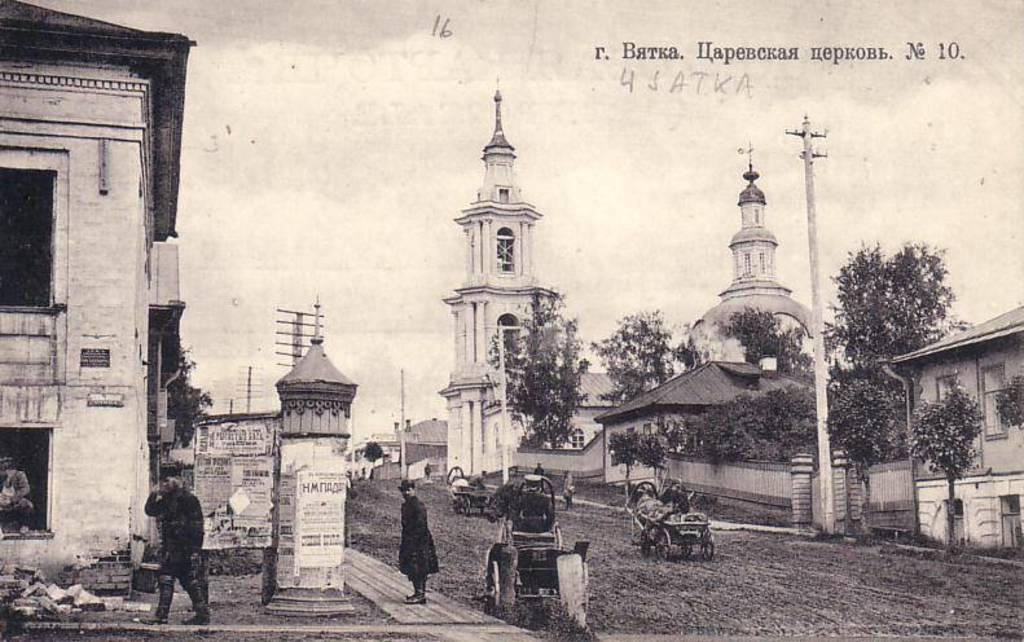What can be seen in the front of the image? There are persons standing and carts in the front of the image. What is visible in the background of the image? There are buildings, trees, and poles in the background of the image. What type of cable can be seen hanging from the trees in the image? There is no cable visible in the image; only buildings, trees, and poles are present in the background. What kind of wine is being served to the persons in the image? There is no wine present in the image; the focus is on the persons standing and the carts in the front. 